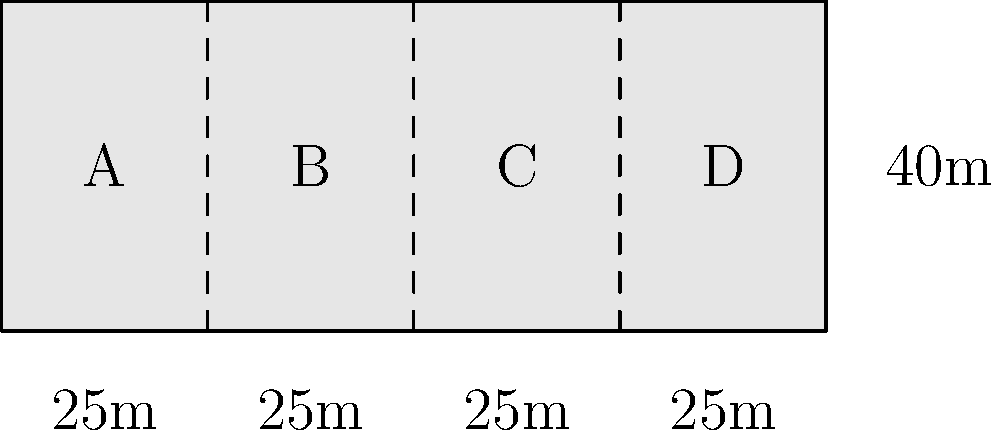A cargo ship is being designed with four watertight compartments (A, B, C, and D) separated by bulkheads. The ship's length is 100 meters and its height is 40 meters. Current regulations require that the ship remain afloat if any two adjacent compartments are flooded. If the optimal design requires equal volumes for all compartments, what is the minimum number of bulkheads needed to meet the regulations, and what is the volume of each compartment in cubic meters? To solve this problem, we need to follow these steps:

1) First, we need to understand the regulation: the ship must remain afloat if any two adjacent compartments are flooded. This means that the total volume of any two adjacent compartments must be less than half of the ship's total volume.

2) The ship's total volume is:
   $V_{total} = 100m \times 40m \times width = 4000 \times width$ cubic meters

3) Let's say we divide the ship into $n$ equal compartments. The volume of each compartment would be:
   $V_{compartment} = \frac{4000 \times width}{n}$ cubic meters

4) For the ship to remain afloat, we need:
   $2 \times V_{compartment} < \frac{1}{2} \times V_{total}$

5) Substituting the values:
   $2 \times \frac{4000 \times width}{n} < \frac{1}{2} \times 4000 \times width$

6) Simplifying:
   $\frac{8000}{n} < 2000$
   $4 < n$

7) Therefore, we need at least 5 compartments to meet the regulation. This means we need 4 bulkheads (one less than the number of compartments).

8) With 5 equal compartments, the volume of each compartment would be:
   $V_{compartment} = \frac{4000 \times width}{5} = 800 \times width$ cubic meters
Answer: 4 bulkheads; $800 \times width$ cubic meters per compartment 